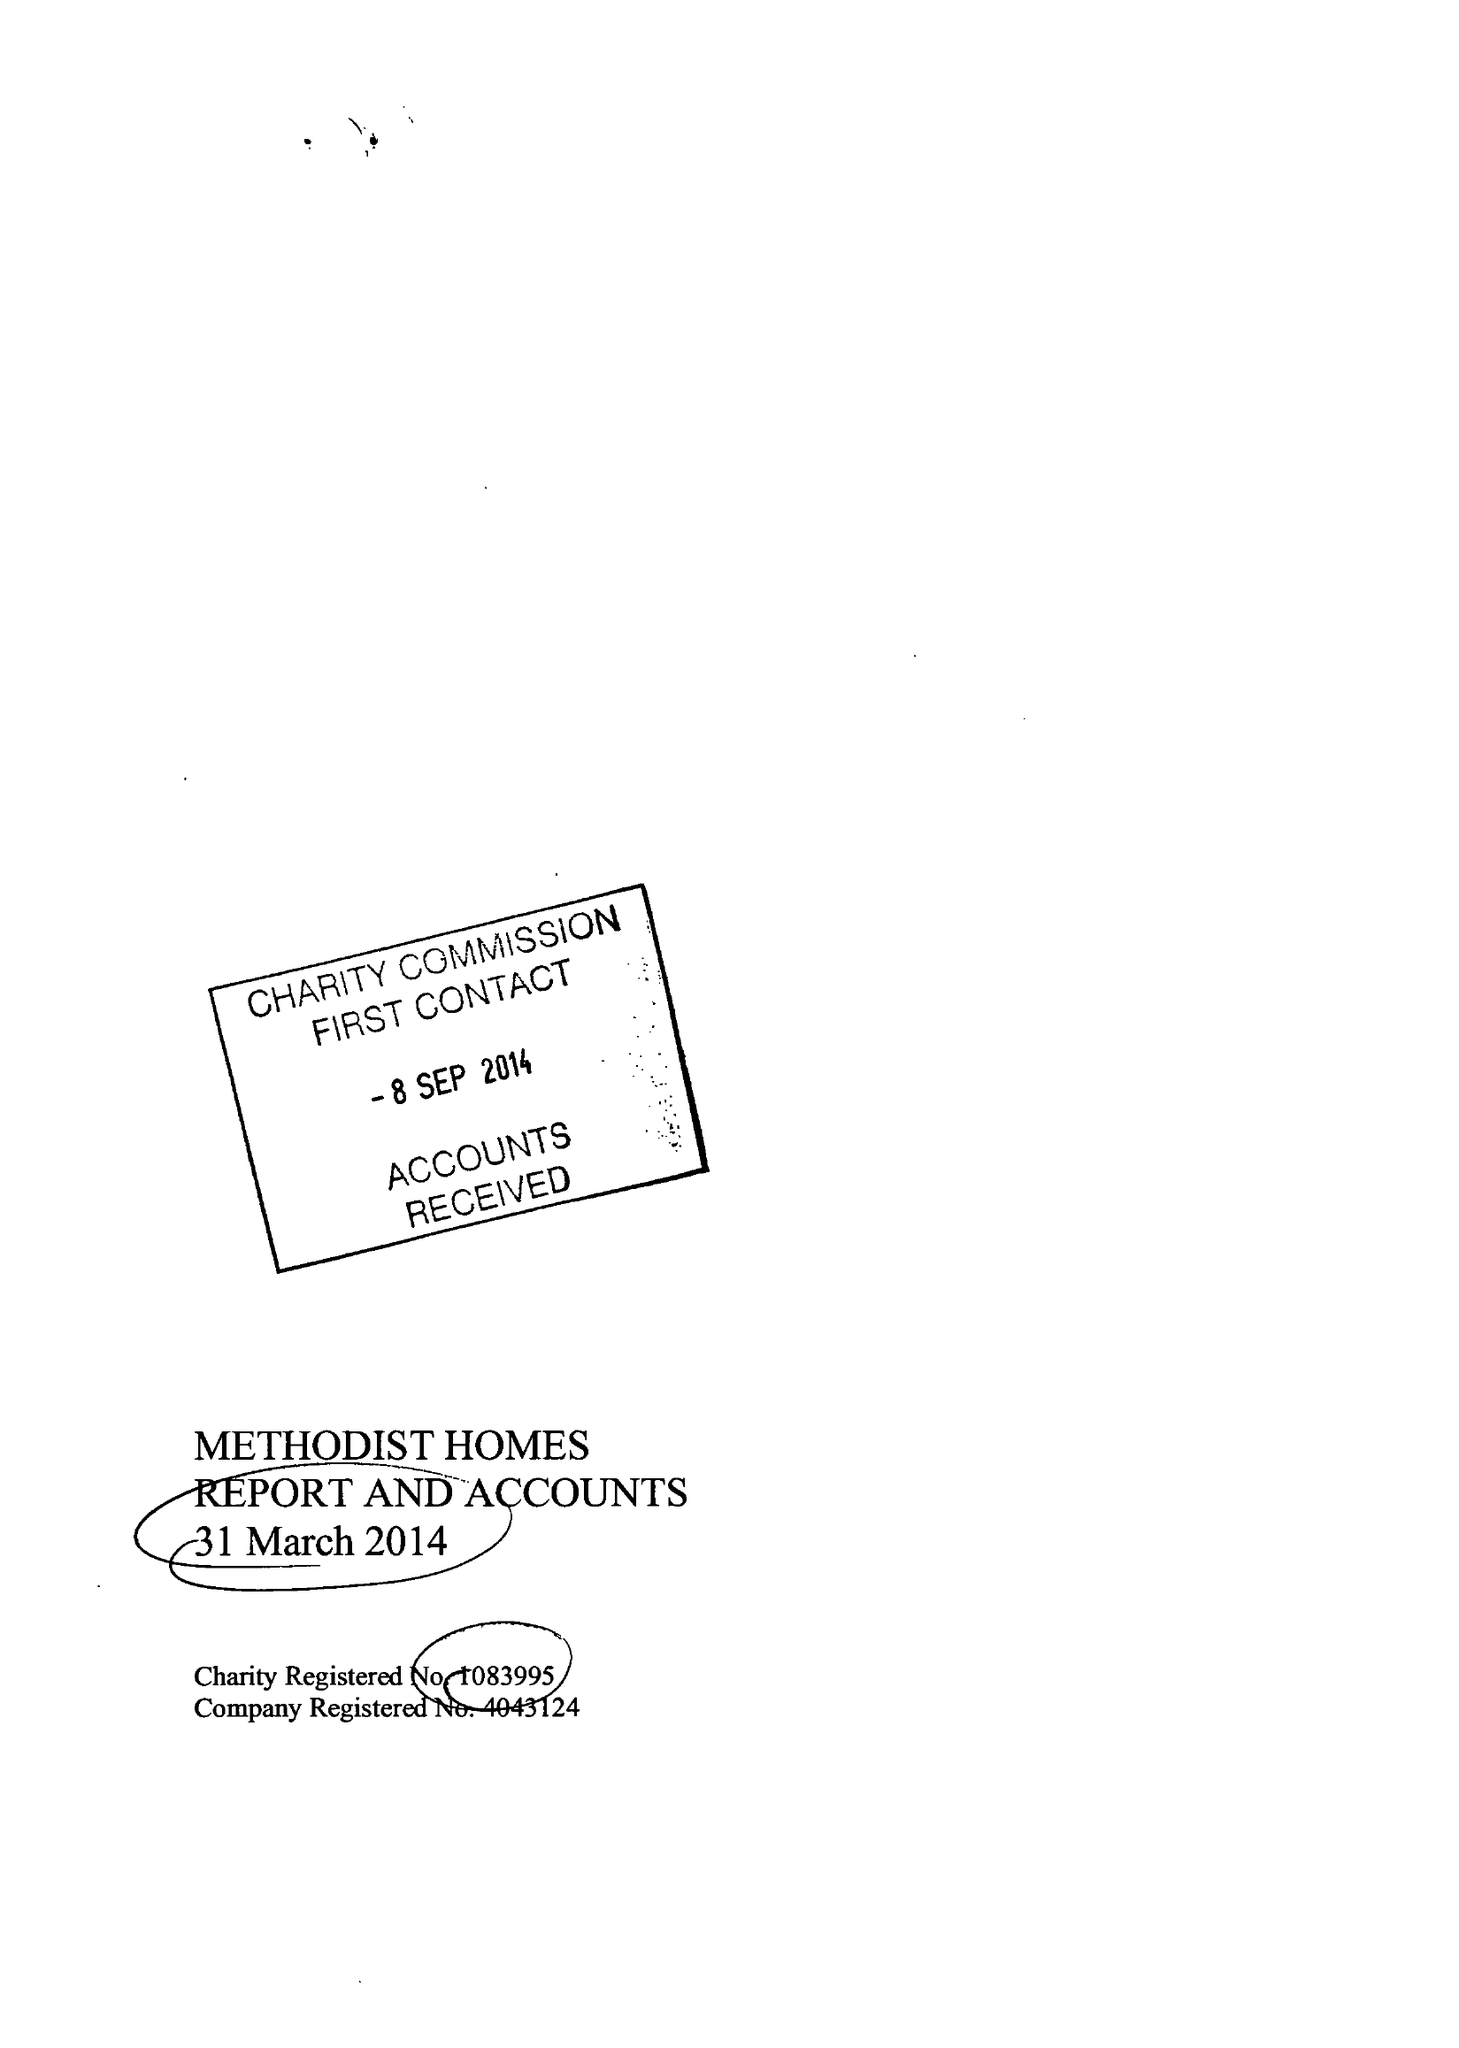What is the value for the report_date?
Answer the question using a single word or phrase. 2014-03-31 